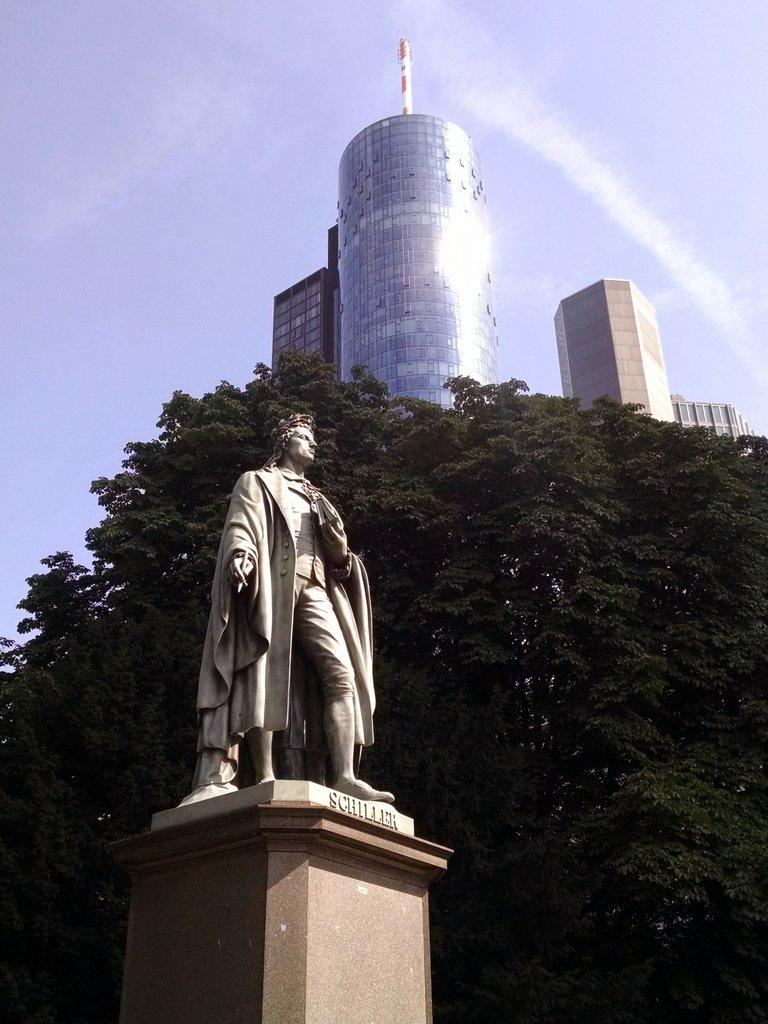What is the main subject in the image? There is a statue in the image. What can be seen in the background of the image? There are trees and buildings in the background of the image. What type of seed is being taught by the statue in the image? There is no seed or teaching depicted in the image; it features a statue with trees and buildings in the background. 